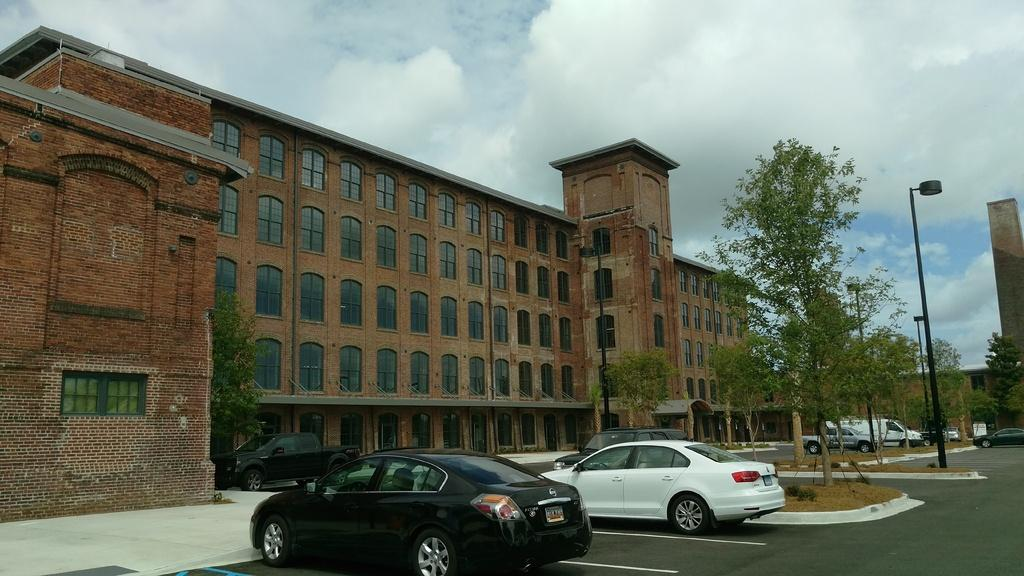What is the main structure in the image? There is a big building with many windows in the image. What can be seen near the building? Different types of cars are parked in front of the building. Where are the cars parked in relation to the building? The cars are parked beside a footpath. What type of vegetation is present between the parked cars? There are trees between the parked cars. How many bedrooms are visible in the image? There are no bedrooms visible in the image, as it features a building with many windows and parked cars. What type of sponge can be seen being used to clean the cars in the image? There is no sponge present in the image, nor is there any indication of car cleaning taking place. --- Facts: 1. There is a person sitting on a bench in the image. 2. The person is reading a book. 3. The bench is located near a body of water. 4. There are trees in the background. 5. The sky is visible in the image. Absurd Topics: parrot, skateboard, volcano Conversation: What is the person in the image doing? The person is sitting on a bench in the image. What activity is the person engaged in while sitting on the bench? The person is reading a book. Where is the bench located in relation to the body of water? The bench is located near a body of water. What can be seen in the background of the image? There are trees in the background. What is visible at the top of the image? The sky is visible in the image. Reasoning: Let's think step by step in order to produce the conversation. We start by identifying the main subject in the image, which is the person sitting on a bench. Then, we describe the person's activity, which is reading a book. Next, we provide context by mentioning the location of the bench near a body of water and the presence of trees in the background. Finally, we mention the sky visible at the top of the image. Absurd Question/Answer: Can you see a parrot flying over the person reading a book in the image? There is no parrot visible in the image. Is the person riding a skateboard while reading the book in the image? No, the person is sitting on a bench while reading the book, not riding a skateboard. 